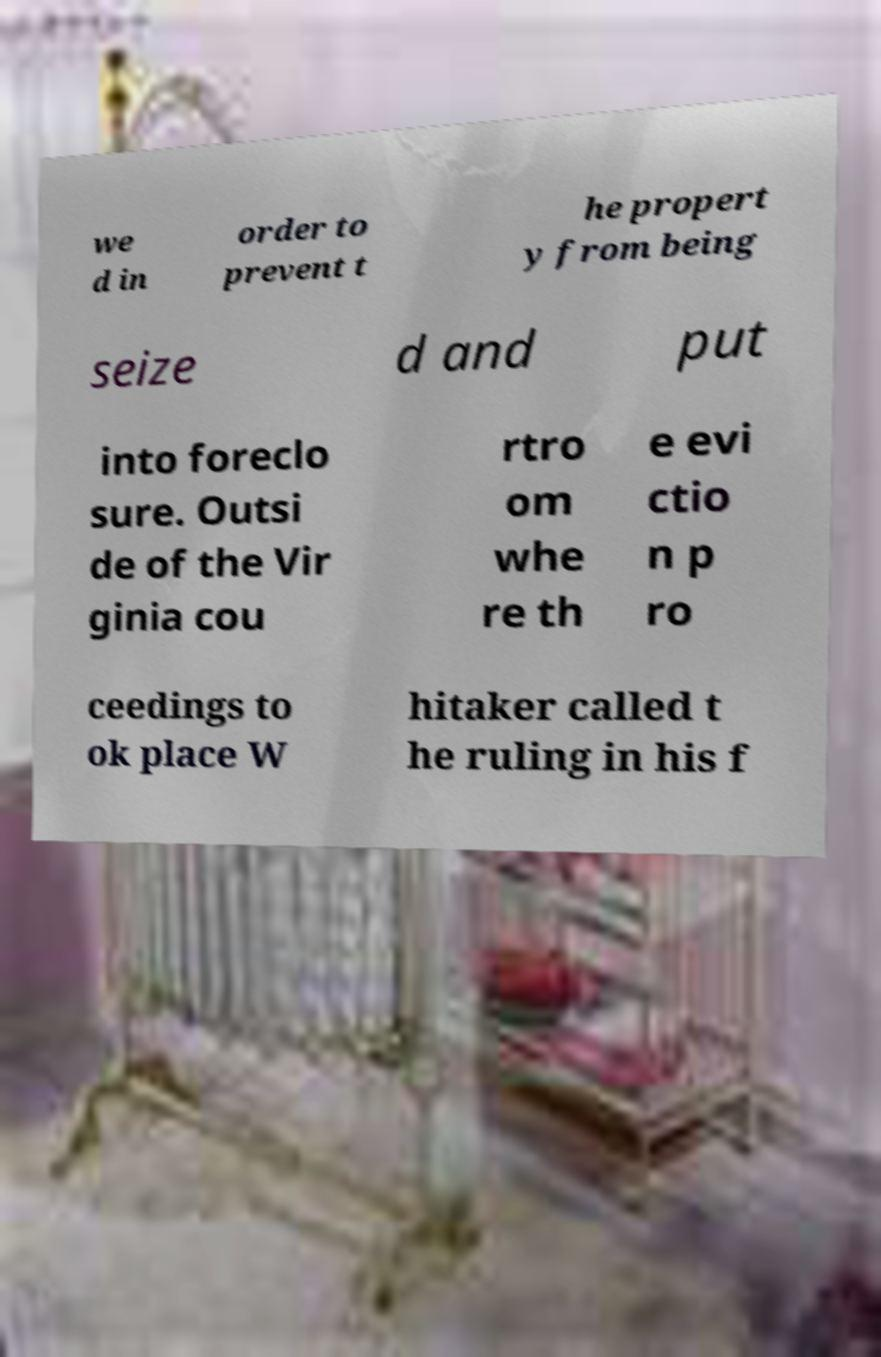I need the written content from this picture converted into text. Can you do that? we d in order to prevent t he propert y from being seize d and put into foreclo sure. Outsi de of the Vir ginia cou rtro om whe re th e evi ctio n p ro ceedings to ok place W hitaker called t he ruling in his f 